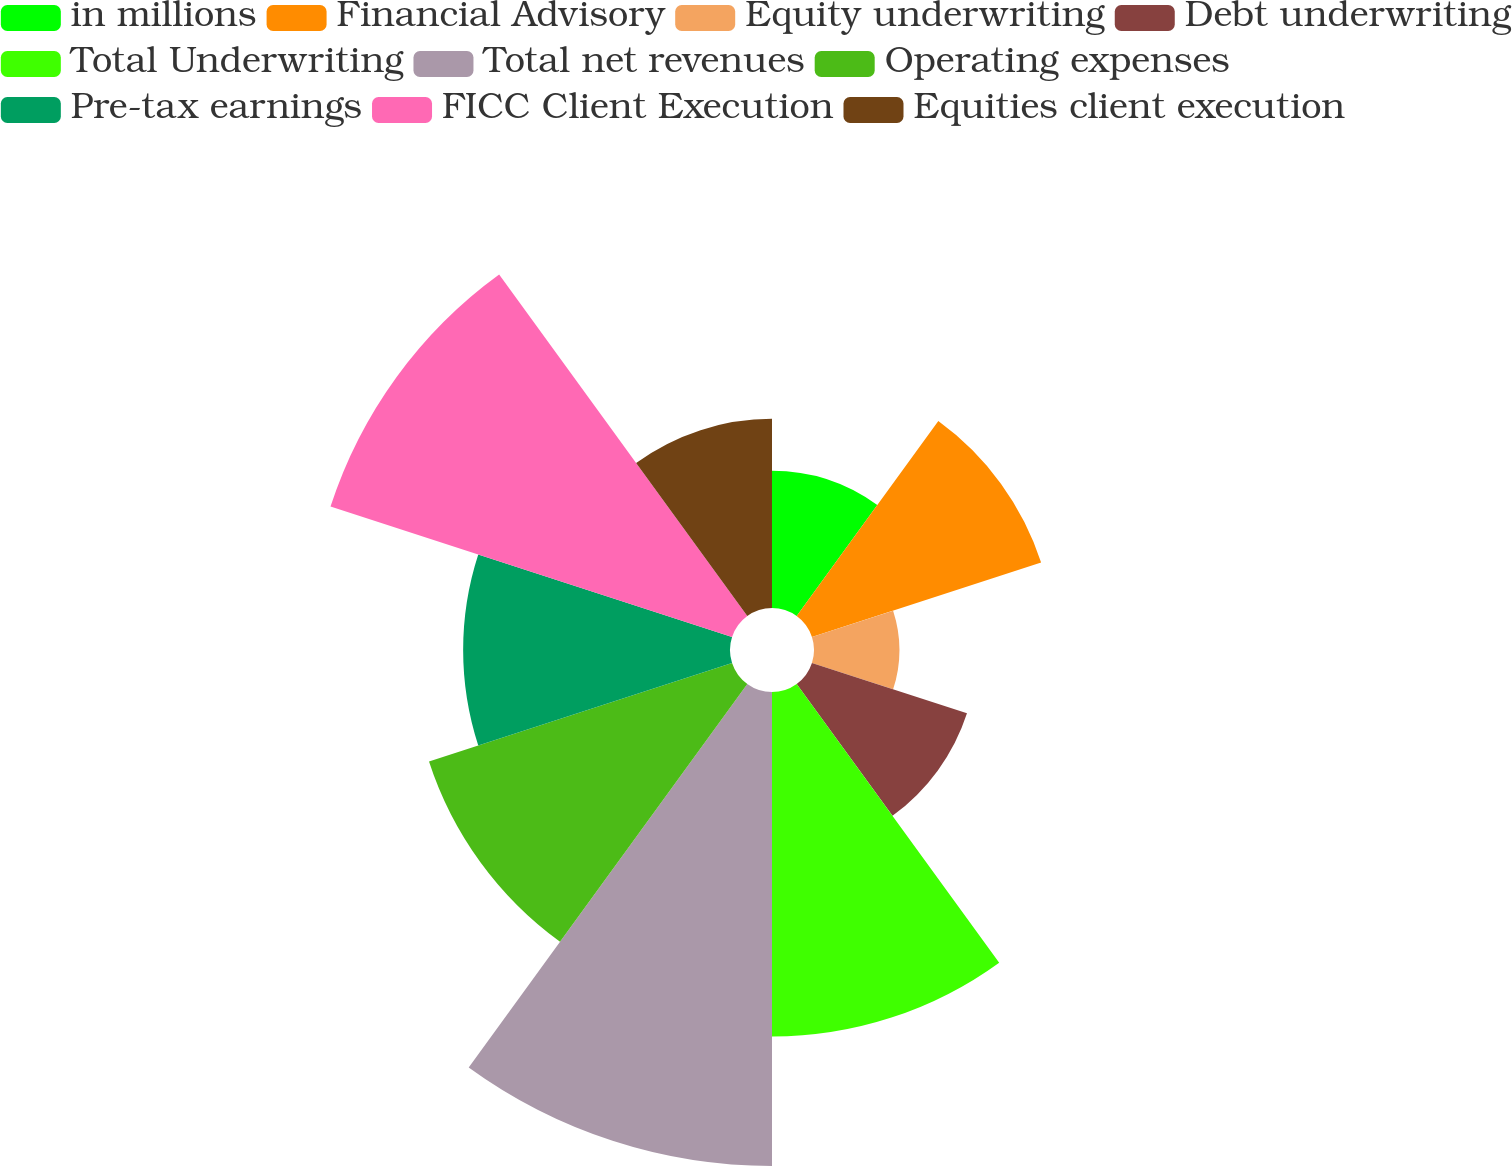Convert chart to OTSL. <chart><loc_0><loc_0><loc_500><loc_500><pie_chart><fcel>in millions<fcel>Financial Advisory<fcel>Equity underwriting<fcel>Debt underwriting<fcel>Total Underwriting<fcel>Total net revenues<fcel>Operating expenses<fcel>Pre-tax earnings<fcel>FICC Client Execution<fcel>Equities client execution<nl><fcel>5.19%<fcel>9.12%<fcel>3.23%<fcel>6.17%<fcel>13.04%<fcel>17.94%<fcel>12.06%<fcel>10.1%<fcel>15.98%<fcel>7.16%<nl></chart> 